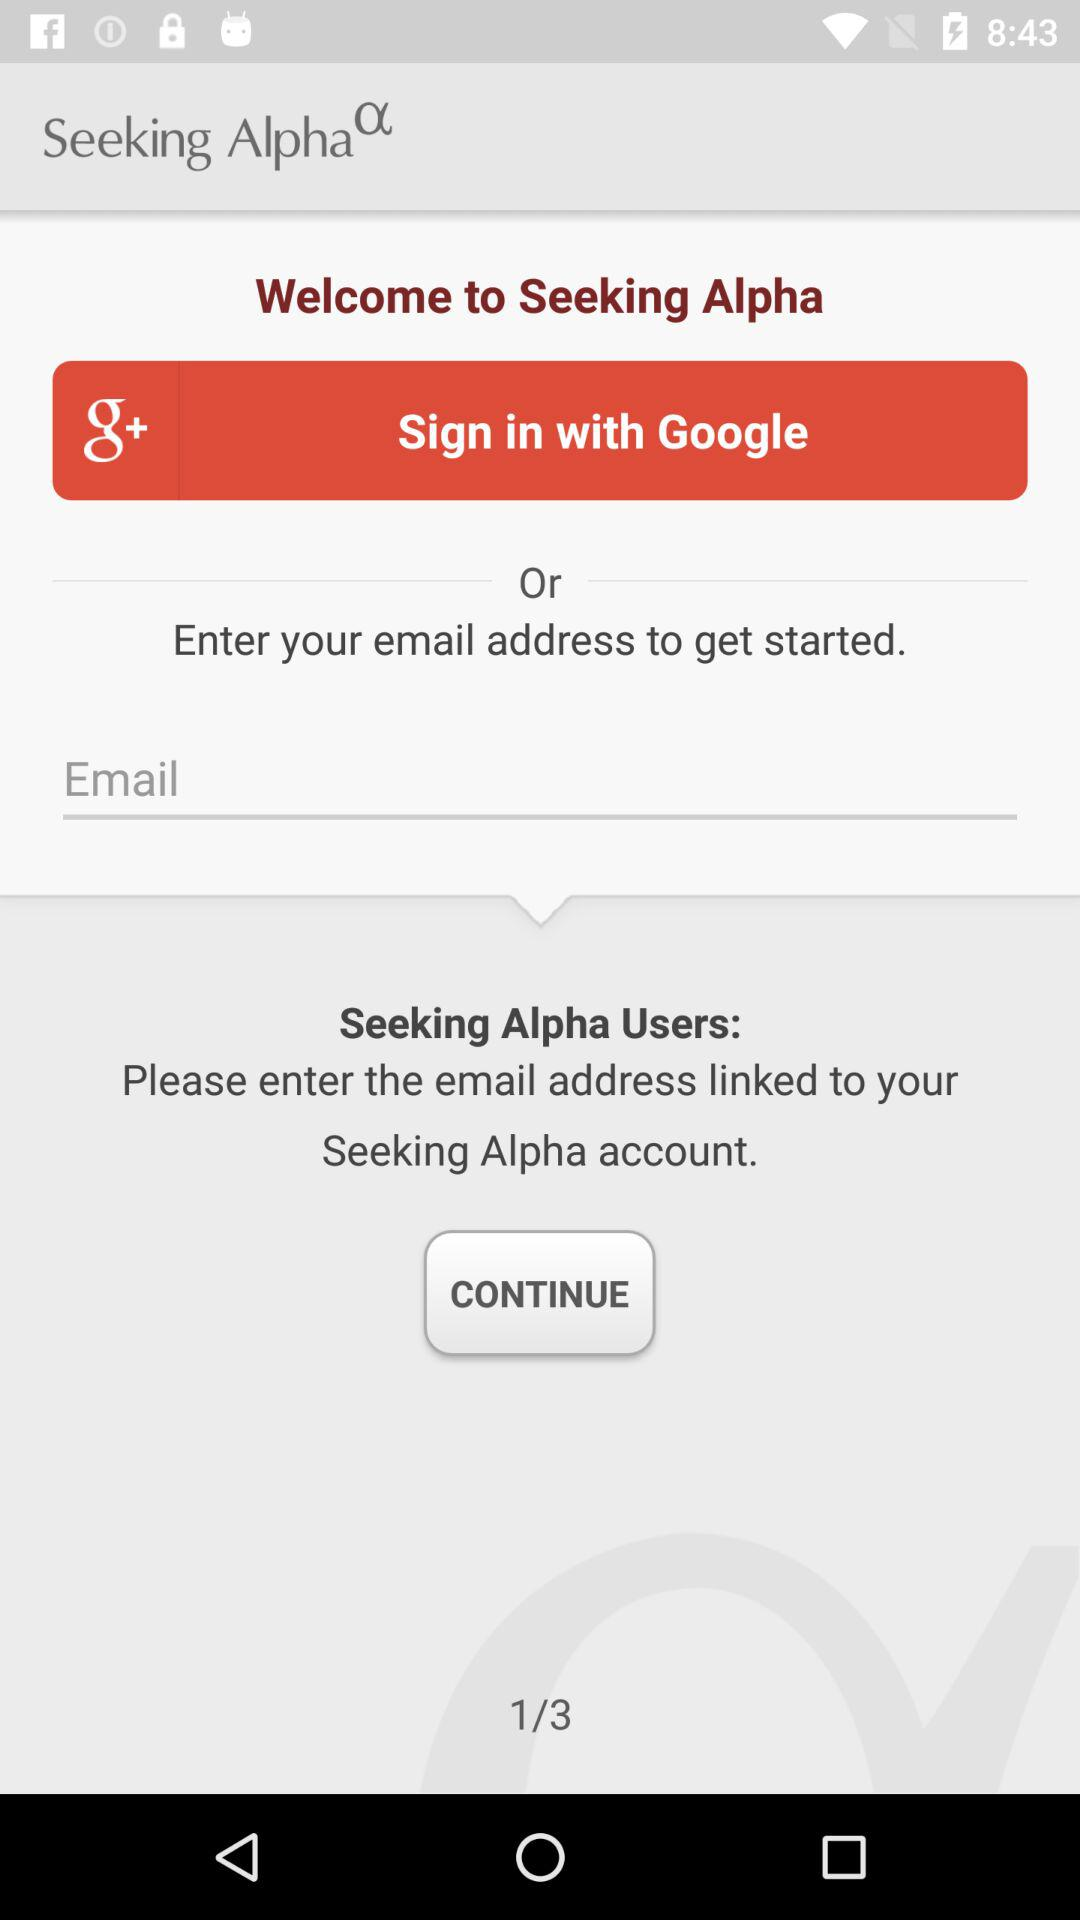What application can the user sign in with? The user can sign in with "Google". 